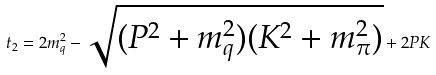Convert formula to latex. <formula><loc_0><loc_0><loc_500><loc_500>t _ { 2 } = 2 m _ { q } ^ { 2 } - \sqrt { ( P ^ { 2 } + m _ { q } ^ { 2 } ) ( K ^ { 2 } + m _ { \pi } ^ { 2 } ) } + 2 P K</formula> 